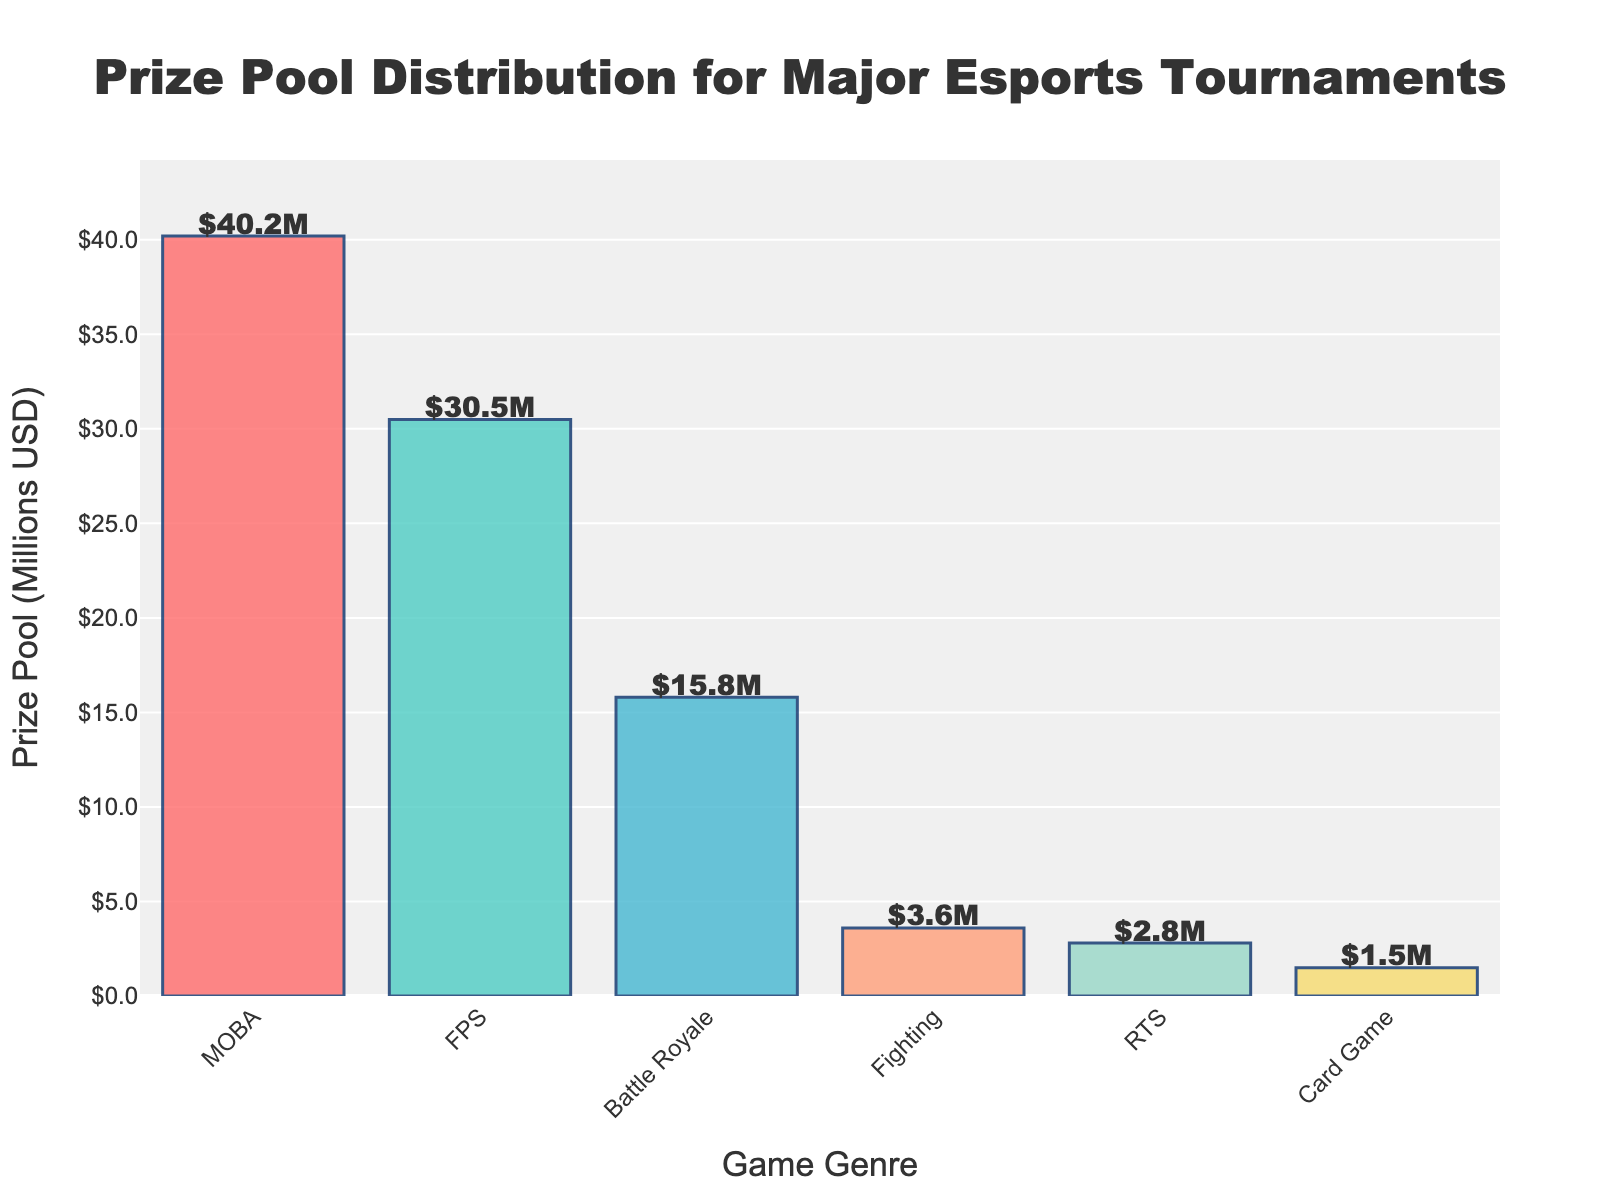What game genre has the highest prize pool? The bar for MOBA games is the tallest, indicating the highest prize pool
Answer: MOBA Which game genres have prize pools less than 10 million USD? The bars for Fighting, RTS, and Card Game are below the 10 million mark
Answer: Fighting, RTS, Card Game How much higher is the prize pool for FPS games compared to Card Games? FPS prize pool is 30.5M, Card Game prize pool is 1.5M. The difference is 30.5 - 1.5 = 29M
Answer: 29M What is the total prize pool for MOBA and FPS genres combined? MOBA prize pool is 40.2M, FPS prize pool is 30.5M. Sum is 40.2 + 30.5 = 70.7M
Answer: 70.7M Which game genre has a prize pool closest to 4 million USD? The Fighting genre has a prize pool of 3.6M, which is closest to 4M
Answer: Fighting Among the given genres, which two have the smallest difference in prize pools? Comparing differences: Battle Royale vs Fighting (12.2M), Fighting vs RTS (0.8M), RTS vs Card Game (1.3M). The smallest difference is between Fighting and RTS
Answer: Fighting and RTS How does the visual attribute of bar height correspond to the prize pool value? Taller bars represent higher prize pools, shorter bars represent lower prize pools
Answer: Height corresponds to value What is the average prize pool of all the genres? Total Prize Pool = 40.2 + 30.5 + 15.8 + 3.6 + 2.8 + 1.5 = 94.4M, Number of Genres = 6. Average = 94.4 / 6 = 15.73M
Answer: 15.73M What is the range of prize pool values displayed in the chart? Highest value is 40.2M (MOBA), lowest value is 1.5M (Card Game). Range = 40.2 - 1.5 = 38.7M
Answer: 38.7M 